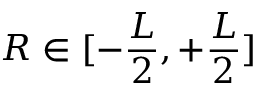<formula> <loc_0><loc_0><loc_500><loc_500>R \in [ - \frac { L } { 2 } , + \frac { L } { 2 } ]</formula> 